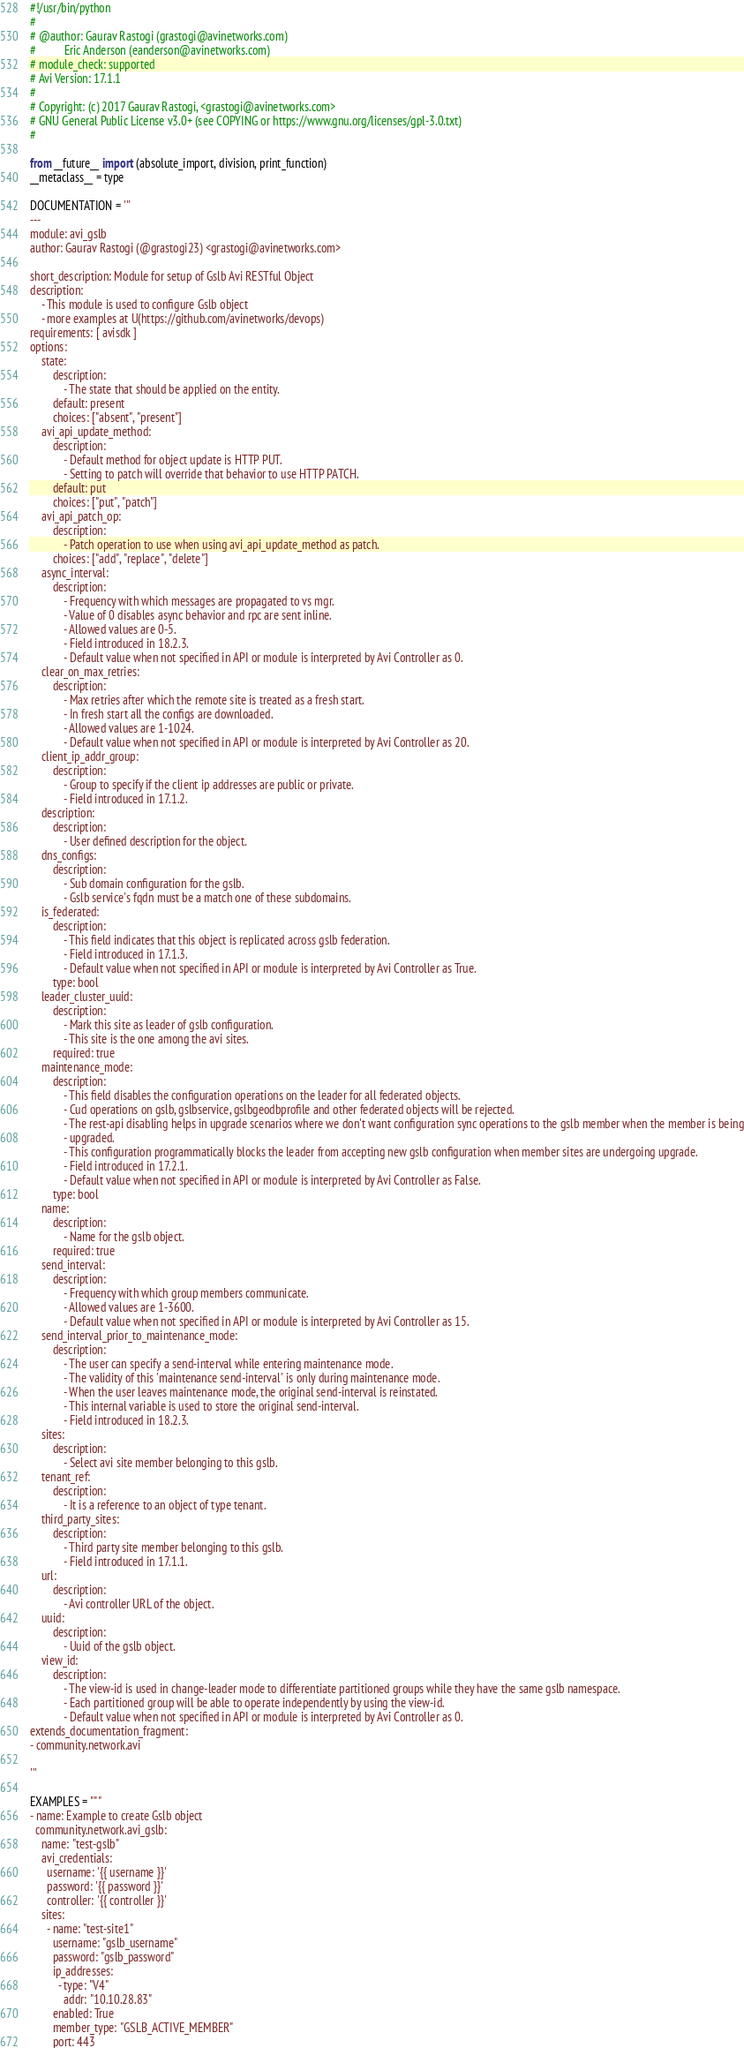Convert code to text. <code><loc_0><loc_0><loc_500><loc_500><_Python_>#!/usr/bin/python
#
# @author: Gaurav Rastogi (grastogi@avinetworks.com)
#          Eric Anderson (eanderson@avinetworks.com)
# module_check: supported
# Avi Version: 17.1.1
#
# Copyright: (c) 2017 Gaurav Rastogi, <grastogi@avinetworks.com>
# GNU General Public License v3.0+ (see COPYING or https://www.gnu.org/licenses/gpl-3.0.txt)
#

from __future__ import (absolute_import, division, print_function)
__metaclass__ = type

DOCUMENTATION = '''
---
module: avi_gslb
author: Gaurav Rastogi (@grastogi23) <grastogi@avinetworks.com>

short_description: Module for setup of Gslb Avi RESTful Object
description:
    - This module is used to configure Gslb object
    - more examples at U(https://github.com/avinetworks/devops)
requirements: [ avisdk ]
options:
    state:
        description:
            - The state that should be applied on the entity.
        default: present
        choices: ["absent", "present"]
    avi_api_update_method:
        description:
            - Default method for object update is HTTP PUT.
            - Setting to patch will override that behavior to use HTTP PATCH.
        default: put
        choices: ["put", "patch"]
    avi_api_patch_op:
        description:
            - Patch operation to use when using avi_api_update_method as patch.
        choices: ["add", "replace", "delete"]
    async_interval:
        description:
            - Frequency with which messages are propagated to vs mgr.
            - Value of 0 disables async behavior and rpc are sent inline.
            - Allowed values are 0-5.
            - Field introduced in 18.2.3.
            - Default value when not specified in API or module is interpreted by Avi Controller as 0.
    clear_on_max_retries:
        description:
            - Max retries after which the remote site is treated as a fresh start.
            - In fresh start all the configs are downloaded.
            - Allowed values are 1-1024.
            - Default value when not specified in API or module is interpreted by Avi Controller as 20.
    client_ip_addr_group:
        description:
            - Group to specify if the client ip addresses are public or private.
            - Field introduced in 17.1.2.
    description:
        description:
            - User defined description for the object.
    dns_configs:
        description:
            - Sub domain configuration for the gslb.
            - Gslb service's fqdn must be a match one of these subdomains.
    is_federated:
        description:
            - This field indicates that this object is replicated across gslb federation.
            - Field introduced in 17.1.3.
            - Default value when not specified in API or module is interpreted by Avi Controller as True.
        type: bool
    leader_cluster_uuid:
        description:
            - Mark this site as leader of gslb configuration.
            - This site is the one among the avi sites.
        required: true
    maintenance_mode:
        description:
            - This field disables the configuration operations on the leader for all federated objects.
            - Cud operations on gslb, gslbservice, gslbgeodbprofile and other federated objects will be rejected.
            - The rest-api disabling helps in upgrade scenarios where we don't want configuration sync operations to the gslb member when the member is being
            - upgraded.
            - This configuration programmatically blocks the leader from accepting new gslb configuration when member sites are undergoing upgrade.
            - Field introduced in 17.2.1.
            - Default value when not specified in API or module is interpreted by Avi Controller as False.
        type: bool
    name:
        description:
            - Name for the gslb object.
        required: true
    send_interval:
        description:
            - Frequency with which group members communicate.
            - Allowed values are 1-3600.
            - Default value when not specified in API or module is interpreted by Avi Controller as 15.
    send_interval_prior_to_maintenance_mode:
        description:
            - The user can specify a send-interval while entering maintenance mode.
            - The validity of this 'maintenance send-interval' is only during maintenance mode.
            - When the user leaves maintenance mode, the original send-interval is reinstated.
            - This internal variable is used to store the original send-interval.
            - Field introduced in 18.2.3.
    sites:
        description:
            - Select avi site member belonging to this gslb.
    tenant_ref:
        description:
            - It is a reference to an object of type tenant.
    third_party_sites:
        description:
            - Third party site member belonging to this gslb.
            - Field introduced in 17.1.1.
    url:
        description:
            - Avi controller URL of the object.
    uuid:
        description:
            - Uuid of the gslb object.
    view_id:
        description:
            - The view-id is used in change-leader mode to differentiate partitioned groups while they have the same gslb namespace.
            - Each partitioned group will be able to operate independently by using the view-id.
            - Default value when not specified in API or module is interpreted by Avi Controller as 0.
extends_documentation_fragment:
- community.network.avi

'''

EXAMPLES = """
- name: Example to create Gslb object
  community.network.avi_gslb:
    name: "test-gslb"
    avi_credentials:
      username: '{{ username }}'
      password: '{{ password }}'
      controller: '{{ controller }}'
    sites:
      - name: "test-site1"
        username: "gslb_username"
        password: "gslb_password"
        ip_addresses:
          - type: "V4"
            addr: "10.10.28.83"
        enabled: True
        member_type: "GSLB_ACTIVE_MEMBER"
        port: 443</code> 